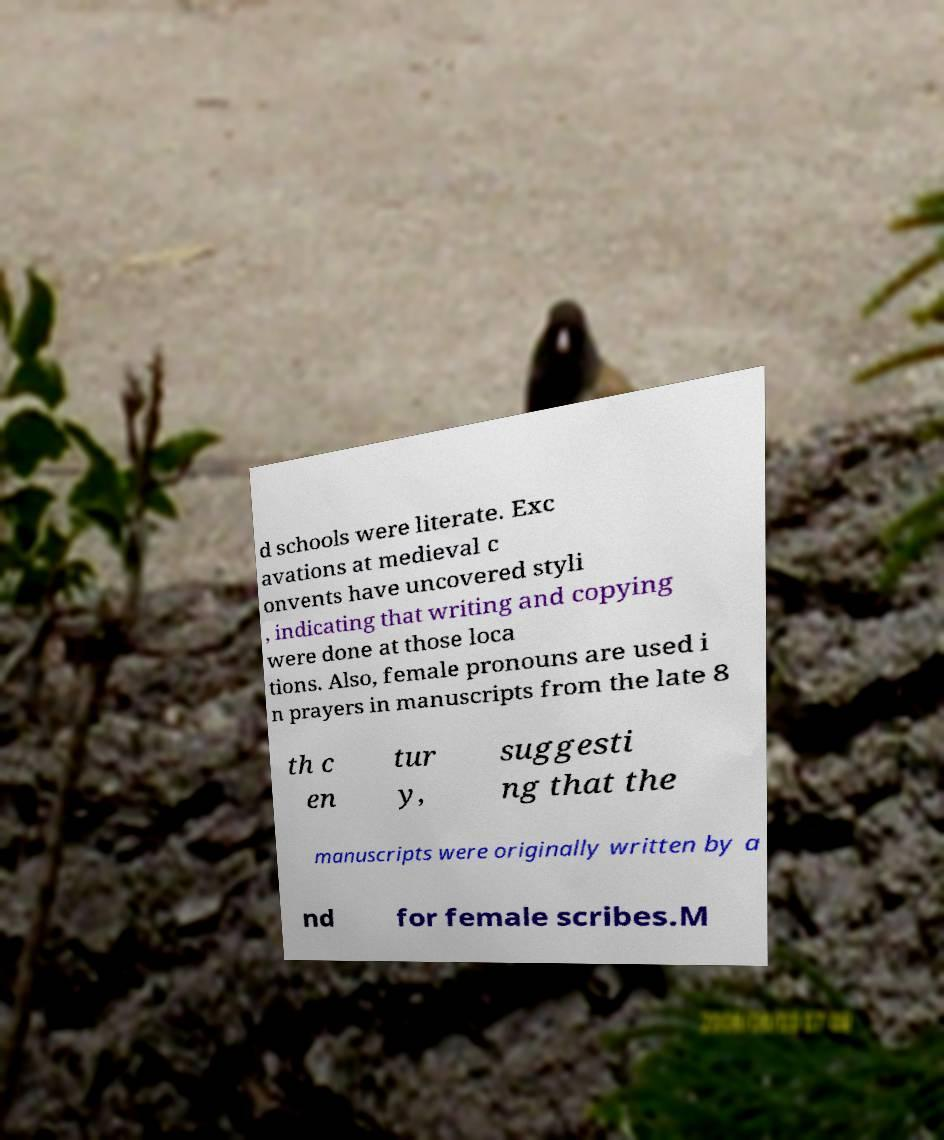Please read and relay the text visible in this image. What does it say? d schools were literate. Exc avations at medieval c onvents have uncovered styli , indicating that writing and copying were done at those loca tions. Also, female pronouns are used i n prayers in manuscripts from the late 8 th c en tur y, suggesti ng that the manuscripts were originally written by a nd for female scribes.M 